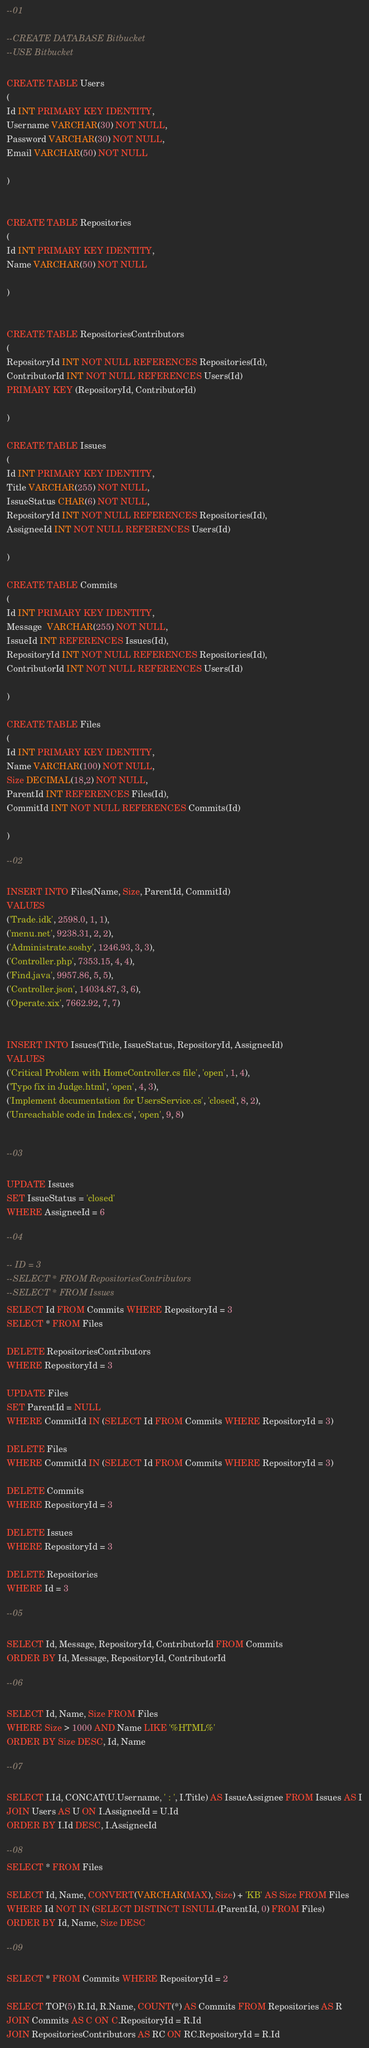Convert code to text. <code><loc_0><loc_0><loc_500><loc_500><_SQL_>--01

--CREATE DATABASE Bitbucket
--USE Bitbucket

CREATE TABLE Users
(
Id INT PRIMARY KEY IDENTITY,
Username VARCHAR(30) NOT NULL,
Password VARCHAR(30) NOT NULL,
Email VARCHAR(50) NOT NULL

)


CREATE TABLE Repositories
(
Id INT PRIMARY KEY IDENTITY,
Name VARCHAR(50) NOT NULL

)


CREATE TABLE RepositoriesContributors
(
RepositoryId INT NOT NULL REFERENCES Repositories(Id),
ContributorId INT NOT NULL REFERENCES Users(Id)
PRIMARY KEY (RepositoryId, ContributorId)

)

CREATE TABLE Issues
(
Id INT PRIMARY KEY IDENTITY,
Title VARCHAR(255) NOT NULL,
IssueStatus CHAR(6) NOT NULL,
RepositoryId INT NOT NULL REFERENCES Repositories(Id),
AssigneeId INT NOT NULL REFERENCES Users(Id)

)

CREATE TABLE Commits
(
Id INT PRIMARY KEY IDENTITY,
Message  VARCHAR(255) NOT NULL,
IssueId INT REFERENCES Issues(Id),
RepositoryId INT NOT NULL REFERENCES Repositories(Id),
ContributorId INT NOT NULL REFERENCES Users(Id)

)

CREATE TABLE Files
(
Id INT PRIMARY KEY IDENTITY,
Name VARCHAR(100) NOT NULL,
Size DECIMAL(18,2) NOT NULL,
ParentId INT REFERENCES Files(Id),
CommitId INT NOT NULL REFERENCES Commits(Id)

)

--02

INSERT INTO Files(Name, Size, ParentId, CommitId)
VALUES 
('Trade.idk', 2598.0, 1, 1),
('menu.net', 9238.31, 2, 2),
('Administrate.soshy', 1246.93, 3, 3),
('Controller.php', 7353.15, 4, 4),
('Find.java', 9957.86, 5, 5),
('Controller.json', 14034.87, 3, 6),
('Operate.xix', 7662.92, 7, 7)


INSERT INTO Issues(Title, IssueStatus, RepositoryId, AssigneeId)
VALUES
('Critical Problem with HomeController.cs file', 'open', 1, 4),
('Typo fix in Judge.html', 'open', 4, 3),
('Implement documentation for UsersService.cs', 'closed', 8, 2),
('Unreachable code in Index.cs', 'open', 9, 8)


--03

UPDATE Issues
SET IssueStatus = 'closed'
WHERE AssigneeId = 6

--04

-- ID = 3
--SELECT * FROM RepositoriesContributors
--SELECT * FROM Issues
SELECT Id FROM Commits WHERE RepositoryId = 3
SELECT * FROM Files

DELETE RepositoriesContributors
WHERE RepositoryId = 3

UPDATE Files
SET ParentId = NULL
WHERE CommitId IN (SELECT Id FROM Commits WHERE RepositoryId = 3)

DELETE Files 
WHERE CommitId IN (SELECT Id FROM Commits WHERE RepositoryId = 3)

DELETE Commits
WHERE RepositoryId = 3

DELETE Issues
WHERE RepositoryId = 3

DELETE Repositories
WHERE Id = 3

--05

SELECT Id, Message, RepositoryId, ContributorId FROM Commits
ORDER BY Id, Message, RepositoryId, ContributorId

--06

SELECT Id, Name, Size FROM Files
WHERE Size > 1000 AND Name LIKE '%HTML%'
ORDER BY Size DESC, Id, Name

--07

SELECT I.Id, CONCAT(U.Username, ' : ', I.Title) AS IssueAssignee FROM Issues AS I
JOIN Users AS U ON I.AssigneeId = U.Id
ORDER BY I.Id DESC, I.AssigneeId 

--08
SELECT * FROM Files

SELECT Id, Name, CONVERT(VARCHAR(MAX), Size) + 'KB' AS Size FROM Files
WHERE Id NOT IN (SELECT DISTINCT ISNULL(ParentId, 0) FROM Files)
ORDER BY Id, Name, Size DESC

--09

SELECT * FROM Commits WHERE RepositoryId = 2

SELECT TOP(5) R.Id, R.Name, COUNT(*) AS Commits FROM Repositories AS R
JOIN Commits AS C ON C.RepositoryId = R.Id
JOIN RepositoriesContributors AS RC ON RC.RepositoryId = R.Id</code> 